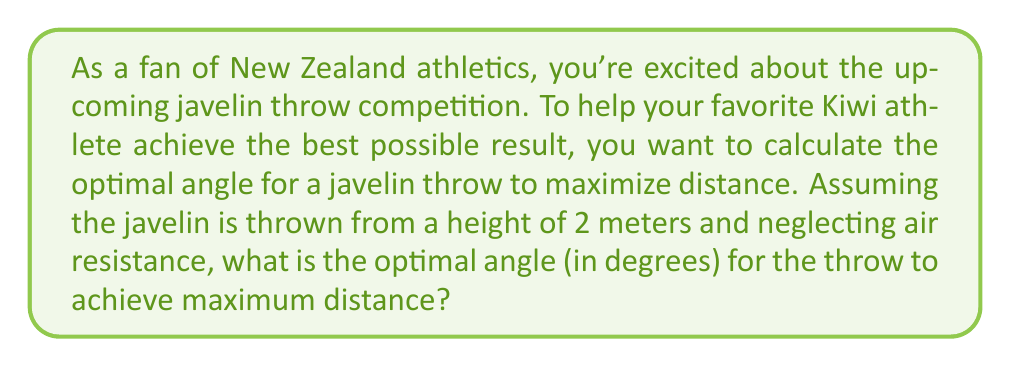Can you answer this question? Let's approach this step-by-step:

1) The trajectory of a javelin (neglecting air resistance) follows a parabolic path described by the equations of motion for projectile motion.

2) The range (R) of a projectile launched from height h with initial velocity v and angle θ is given by:

   $$R = \frac{v \cos θ}{g} \left(v \sin θ + \sqrt{v^2 \sin^2 θ + 2gh}\right)$$

   where g is the acceleration due to gravity (9.8 m/s²).

3) To find the optimal angle, we need to maximize this function with respect to θ. However, the exact solution involves complex calculations.

4) For a projectile launched from ground level (h = 0), the optimal angle is always 45°. However, when launched from a height, the optimal angle is slightly less than 45°.

5) We can use a simplified formula to approximate the optimal angle when launched from a height:

   $$θ_{optimal} ≈ 45° - \frac{1}{2} \arctan\left(\frac{3h}{R}\right)$$

6) The range R in this formula is the range that would be achieved if the javelin were thrown at 45° from ground level. We don't know this exact value, but we can estimate it to be around 90 meters for a top-level thrower.

7) Plugging in our values:
   h = 2 meters
   R ≈ 90 meters

   $$θ_{optimal} ≈ 45° - \frac{1}{2} \arctan\left(\frac{3 * 2}{90}\right)$$
   $$≈ 45° - \frac{1}{2} \arctan(0.0667)$$
   $$≈ 45° - 0.955°$$
   $$≈ 44.045°$$

8) Rounding to the nearest degree, we get 44°.
Answer: 44° 